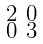<formula> <loc_0><loc_0><loc_500><loc_500>\begin{smallmatrix} 2 & 0 \\ 0 & 3 \end{smallmatrix}</formula> 